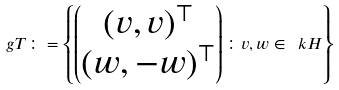Convert formula to latex. <formula><loc_0><loc_0><loc_500><loc_500>\ g T \colon = \left \{ \begin{pmatrix} ( v , v ) ^ { \top } \\ ( w , - w ) ^ { \top } \end{pmatrix} \colon v , w \in \ k H \right \}</formula> 